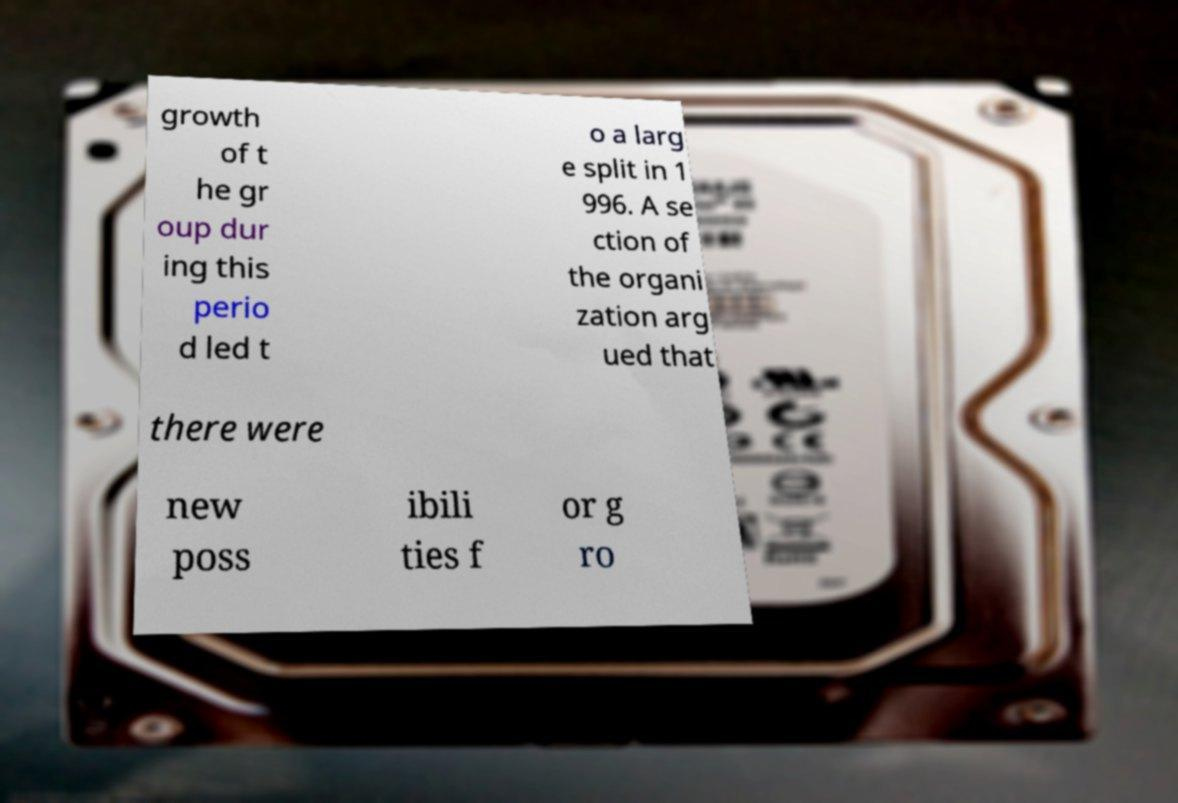I need the written content from this picture converted into text. Can you do that? growth of t he gr oup dur ing this perio d led t o a larg e split in 1 996. A se ction of the organi zation arg ued that there were new poss ibili ties f or g ro 